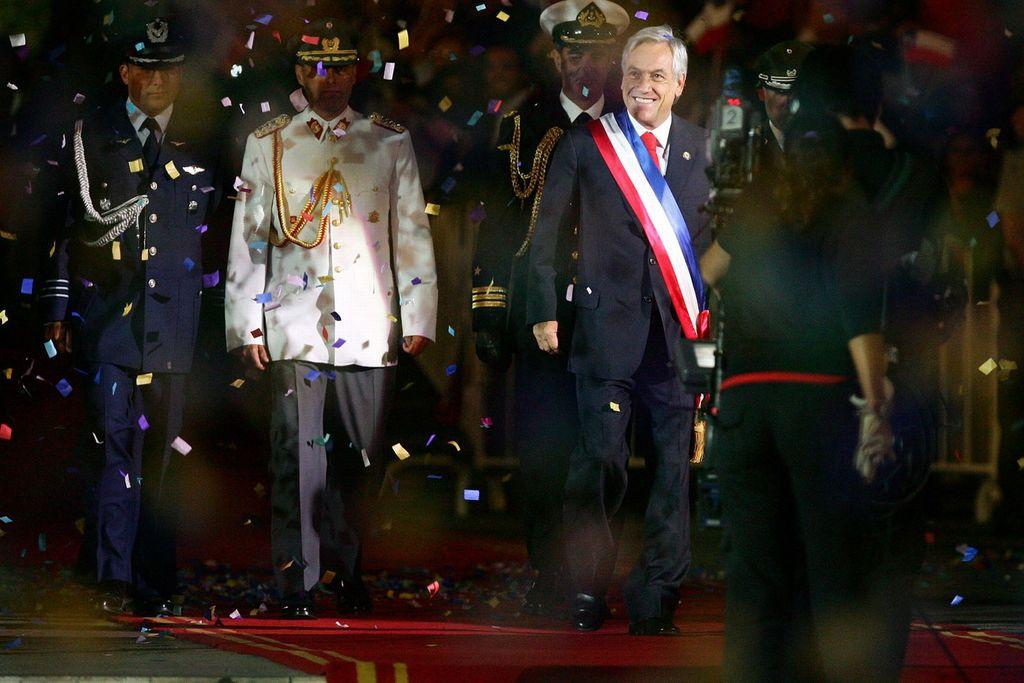What is the color of the carpet on which the people are standing? The carpet is red. What can be seen in front of the people? There is a camera in front of the people. What is the person holding in their hand? The person is holding a white object. What is happening with the papers in the image? There are papers in the air. What type of meat is being served on the shirt of the person in the image? There is no shirt or meat present in the image. Is the person driving a car in the image? There is no car or driving activity depicted in the image. 